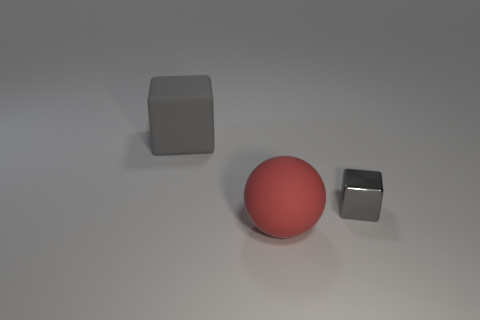Add 3 red matte spheres. How many objects exist? 6 Subtract all blocks. How many objects are left? 1 Add 2 gray things. How many gray things exist? 4 Subtract 1 gray blocks. How many objects are left? 2 Subtract all green balls. Subtract all cyan blocks. How many balls are left? 1 Subtract all shiny blocks. Subtract all big balls. How many objects are left? 1 Add 1 gray metallic blocks. How many gray metallic blocks are left? 2 